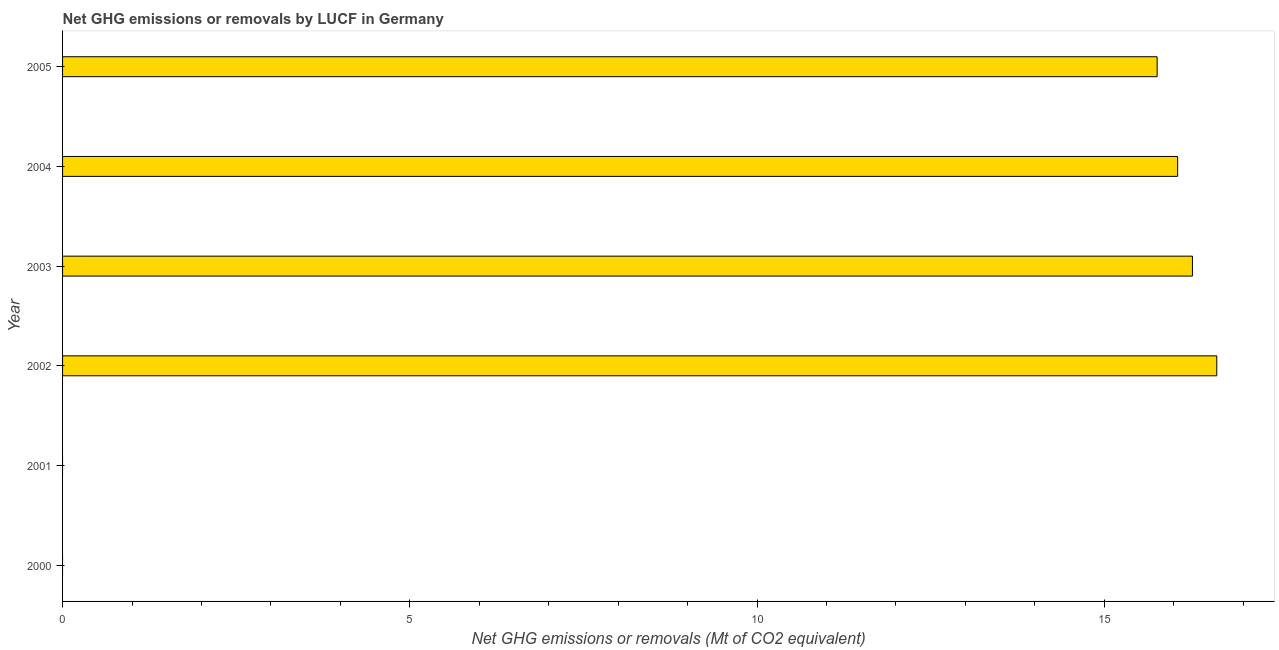Does the graph contain any zero values?
Keep it short and to the point. Yes. What is the title of the graph?
Your response must be concise. Net GHG emissions or removals by LUCF in Germany. What is the label or title of the X-axis?
Give a very brief answer. Net GHG emissions or removals (Mt of CO2 equivalent). What is the label or title of the Y-axis?
Provide a succinct answer. Year. What is the ghg net emissions or removals in 2004?
Provide a succinct answer. 16.06. Across all years, what is the maximum ghg net emissions or removals?
Your answer should be very brief. 16.62. Across all years, what is the minimum ghg net emissions or removals?
Your answer should be very brief. 0. What is the sum of the ghg net emissions or removals?
Keep it short and to the point. 64.71. What is the difference between the ghg net emissions or removals in 2002 and 2004?
Offer a terse response. 0.56. What is the average ghg net emissions or removals per year?
Keep it short and to the point. 10.78. What is the median ghg net emissions or removals?
Provide a succinct answer. 15.91. In how many years, is the ghg net emissions or removals greater than 12 Mt?
Your answer should be compact. 4. Is the difference between the ghg net emissions or removals in 2004 and 2005 greater than the difference between any two years?
Keep it short and to the point. No. What is the difference between the highest and the lowest ghg net emissions or removals?
Your response must be concise. 16.62. Are all the bars in the graph horizontal?
Give a very brief answer. Yes. How many years are there in the graph?
Give a very brief answer. 6. What is the difference between two consecutive major ticks on the X-axis?
Your answer should be very brief. 5. What is the Net GHG emissions or removals (Mt of CO2 equivalent) in 2001?
Ensure brevity in your answer.  0. What is the Net GHG emissions or removals (Mt of CO2 equivalent) of 2002?
Provide a succinct answer. 16.62. What is the Net GHG emissions or removals (Mt of CO2 equivalent) in 2003?
Your answer should be compact. 16.27. What is the Net GHG emissions or removals (Mt of CO2 equivalent) in 2004?
Keep it short and to the point. 16.06. What is the Net GHG emissions or removals (Mt of CO2 equivalent) in 2005?
Make the answer very short. 15.76. What is the difference between the Net GHG emissions or removals (Mt of CO2 equivalent) in 2002 and 2003?
Offer a terse response. 0.35. What is the difference between the Net GHG emissions or removals (Mt of CO2 equivalent) in 2002 and 2004?
Provide a succinct answer. 0.56. What is the difference between the Net GHG emissions or removals (Mt of CO2 equivalent) in 2002 and 2005?
Keep it short and to the point. 0.86. What is the difference between the Net GHG emissions or removals (Mt of CO2 equivalent) in 2003 and 2004?
Keep it short and to the point. 0.21. What is the difference between the Net GHG emissions or removals (Mt of CO2 equivalent) in 2003 and 2005?
Your answer should be compact. 0.51. What is the difference between the Net GHG emissions or removals (Mt of CO2 equivalent) in 2004 and 2005?
Offer a terse response. 0.3. What is the ratio of the Net GHG emissions or removals (Mt of CO2 equivalent) in 2002 to that in 2004?
Offer a terse response. 1.03. What is the ratio of the Net GHG emissions or removals (Mt of CO2 equivalent) in 2002 to that in 2005?
Make the answer very short. 1.05. What is the ratio of the Net GHG emissions or removals (Mt of CO2 equivalent) in 2003 to that in 2005?
Provide a succinct answer. 1.03. What is the ratio of the Net GHG emissions or removals (Mt of CO2 equivalent) in 2004 to that in 2005?
Your answer should be very brief. 1.02. 